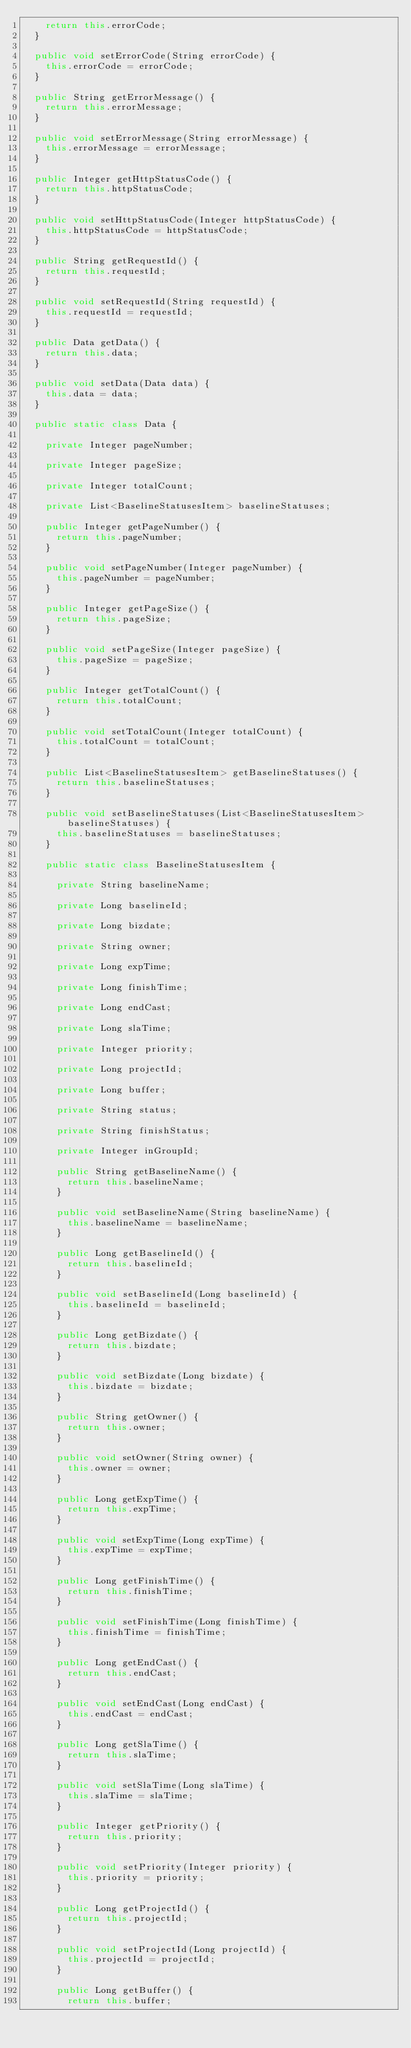<code> <loc_0><loc_0><loc_500><loc_500><_Java_>		return this.errorCode;
	}

	public void setErrorCode(String errorCode) {
		this.errorCode = errorCode;
	}

	public String getErrorMessage() {
		return this.errorMessage;
	}

	public void setErrorMessage(String errorMessage) {
		this.errorMessage = errorMessage;
	}

	public Integer getHttpStatusCode() {
		return this.httpStatusCode;
	}

	public void setHttpStatusCode(Integer httpStatusCode) {
		this.httpStatusCode = httpStatusCode;
	}

	public String getRequestId() {
		return this.requestId;
	}

	public void setRequestId(String requestId) {
		this.requestId = requestId;
	}

	public Data getData() {
		return this.data;
	}

	public void setData(Data data) {
		this.data = data;
	}

	public static class Data {

		private Integer pageNumber;

		private Integer pageSize;

		private Integer totalCount;

		private List<BaselineStatusesItem> baselineStatuses;

		public Integer getPageNumber() {
			return this.pageNumber;
		}

		public void setPageNumber(Integer pageNumber) {
			this.pageNumber = pageNumber;
		}

		public Integer getPageSize() {
			return this.pageSize;
		}

		public void setPageSize(Integer pageSize) {
			this.pageSize = pageSize;
		}

		public Integer getTotalCount() {
			return this.totalCount;
		}

		public void setTotalCount(Integer totalCount) {
			this.totalCount = totalCount;
		}

		public List<BaselineStatusesItem> getBaselineStatuses() {
			return this.baselineStatuses;
		}

		public void setBaselineStatuses(List<BaselineStatusesItem> baselineStatuses) {
			this.baselineStatuses = baselineStatuses;
		}

		public static class BaselineStatusesItem {

			private String baselineName;

			private Long baselineId;

			private Long bizdate;

			private String owner;

			private Long expTime;

			private Long finishTime;

			private Long endCast;

			private Long slaTime;

			private Integer priority;

			private Long projectId;

			private Long buffer;

			private String status;

			private String finishStatus;

			private Integer inGroupId;

			public String getBaselineName() {
				return this.baselineName;
			}

			public void setBaselineName(String baselineName) {
				this.baselineName = baselineName;
			}

			public Long getBaselineId() {
				return this.baselineId;
			}

			public void setBaselineId(Long baselineId) {
				this.baselineId = baselineId;
			}

			public Long getBizdate() {
				return this.bizdate;
			}

			public void setBizdate(Long bizdate) {
				this.bizdate = bizdate;
			}

			public String getOwner() {
				return this.owner;
			}

			public void setOwner(String owner) {
				this.owner = owner;
			}

			public Long getExpTime() {
				return this.expTime;
			}

			public void setExpTime(Long expTime) {
				this.expTime = expTime;
			}

			public Long getFinishTime() {
				return this.finishTime;
			}

			public void setFinishTime(Long finishTime) {
				this.finishTime = finishTime;
			}

			public Long getEndCast() {
				return this.endCast;
			}

			public void setEndCast(Long endCast) {
				this.endCast = endCast;
			}

			public Long getSlaTime() {
				return this.slaTime;
			}

			public void setSlaTime(Long slaTime) {
				this.slaTime = slaTime;
			}

			public Integer getPriority() {
				return this.priority;
			}

			public void setPriority(Integer priority) {
				this.priority = priority;
			}

			public Long getProjectId() {
				return this.projectId;
			}

			public void setProjectId(Long projectId) {
				this.projectId = projectId;
			}

			public Long getBuffer() {
				return this.buffer;</code> 